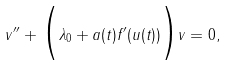<formula> <loc_0><loc_0><loc_500><loc_500>v ^ { \prime \prime } + \Big { ( } \lambda _ { 0 } + a ( t ) f ^ { \prime } ( u ( t ) ) \Big { ) } v = 0 ,</formula> 